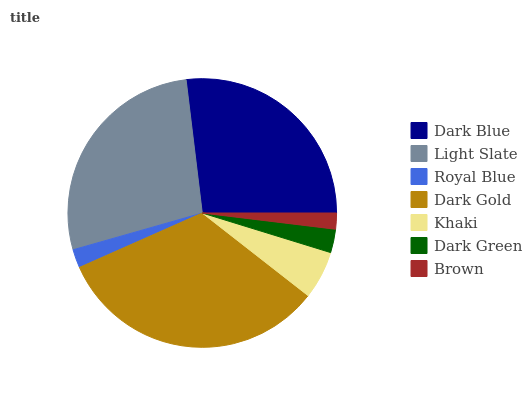Is Brown the minimum?
Answer yes or no. Yes. Is Dark Gold the maximum?
Answer yes or no. Yes. Is Light Slate the minimum?
Answer yes or no. No. Is Light Slate the maximum?
Answer yes or no. No. Is Light Slate greater than Dark Blue?
Answer yes or no. Yes. Is Dark Blue less than Light Slate?
Answer yes or no. Yes. Is Dark Blue greater than Light Slate?
Answer yes or no. No. Is Light Slate less than Dark Blue?
Answer yes or no. No. Is Khaki the high median?
Answer yes or no. Yes. Is Khaki the low median?
Answer yes or no. Yes. Is Light Slate the high median?
Answer yes or no. No. Is Dark Gold the low median?
Answer yes or no. No. 